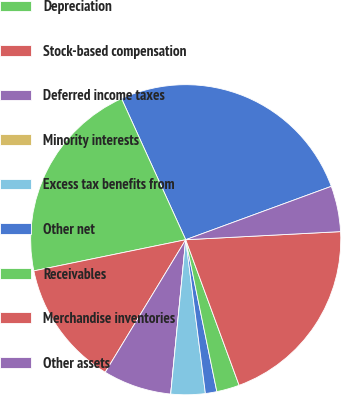<chart> <loc_0><loc_0><loc_500><loc_500><pie_chart><fcel>Net earnings<fcel>Depreciation<fcel>Stock-based compensation<fcel>Deferred income taxes<fcel>Minority interests<fcel>Excess tax benefits from<fcel>Other net<fcel>Receivables<fcel>Merchandise inventories<fcel>Other assets<nl><fcel>26.19%<fcel>21.42%<fcel>13.09%<fcel>7.14%<fcel>0.0%<fcel>3.57%<fcel>1.19%<fcel>2.38%<fcel>20.23%<fcel>4.76%<nl></chart> 